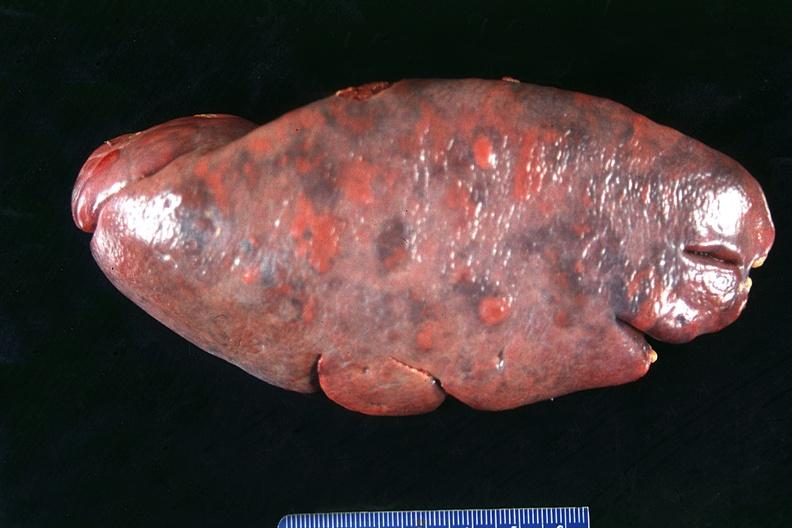does this image show spleen, normal?
Answer the question using a single word or phrase. Yes 